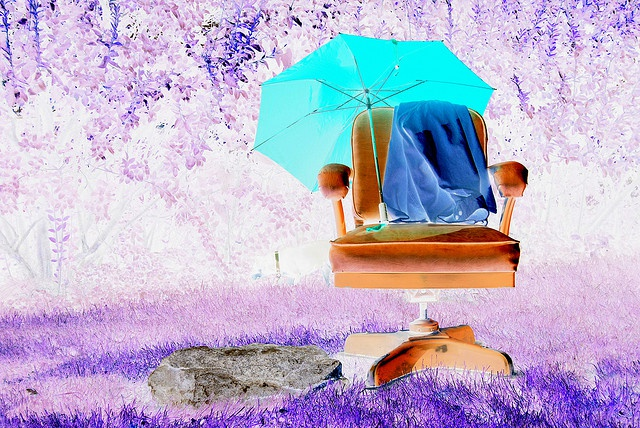Describe the objects in this image and their specific colors. I can see chair in lavender, tan, blue, brown, and maroon tones and umbrella in lavender and cyan tones in this image. 